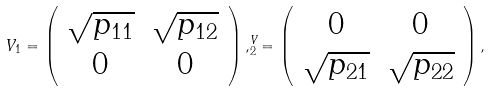Convert formula to latex. <formula><loc_0><loc_0><loc_500><loc_500>V _ { 1 } = \left ( \begin{array} { c c } \sqrt { p _ { 1 1 } } & \sqrt { p _ { 1 2 } } \\ 0 & 0 \end{array} \right ) , ^ { V } _ { 2 } = \left ( \begin{array} { c c } 0 & 0 \\ \sqrt { p _ { 2 1 } } & \sqrt { p _ { 2 2 } } \end{array} \right ) ,</formula> 